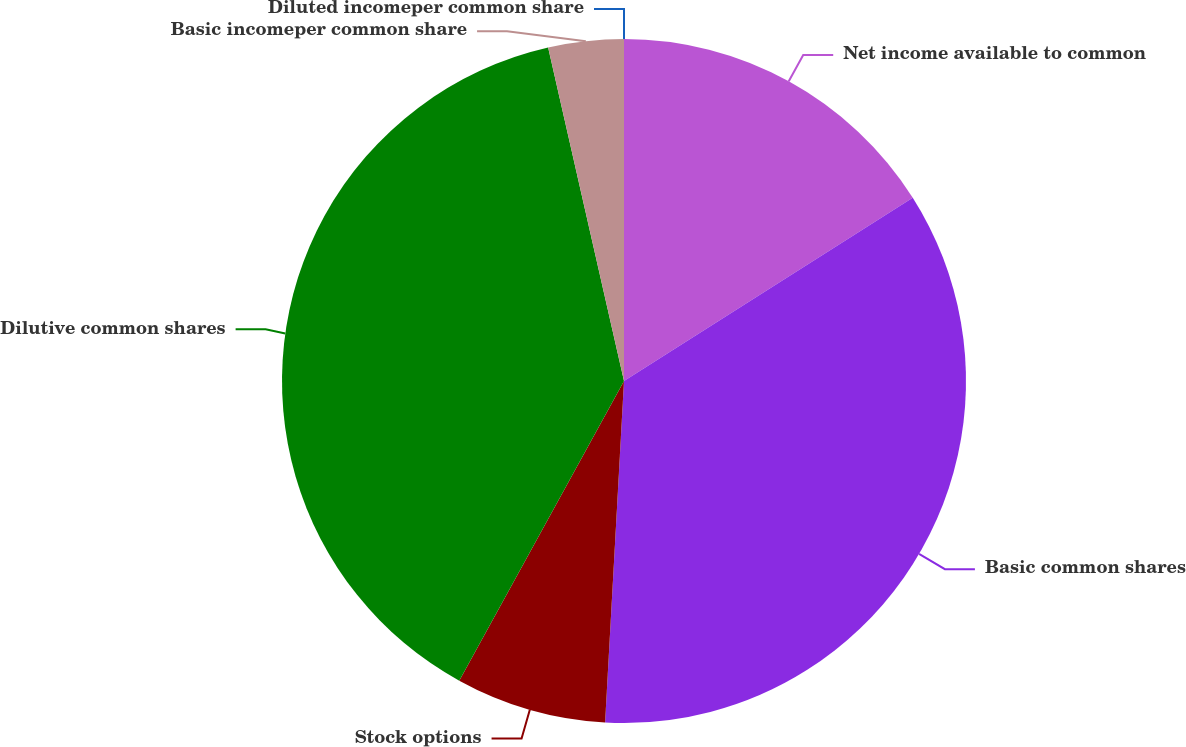<chart> <loc_0><loc_0><loc_500><loc_500><pie_chart><fcel>Net income available to common<fcel>Basic common shares<fcel>Stock options<fcel>Dilutive common shares<fcel>Basic incomeper common share<fcel>Diluted incomeper common share<nl><fcel>16.0%<fcel>34.88%<fcel>7.12%<fcel>38.44%<fcel>3.56%<fcel>0.0%<nl></chart> 